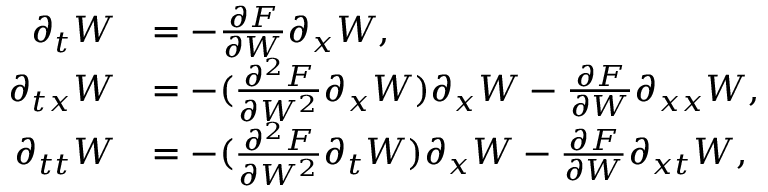<formula> <loc_0><loc_0><loc_500><loc_500>\begin{array} { r l } { \partial _ { t } W } & { = - \frac { \partial F } { \partial W } \partial _ { x } W , } \\ { \partial _ { t x } W } & { = - ( \frac { \partial ^ { 2 } F } { \partial W ^ { 2 } } \partial _ { x } W ) \partial _ { x } W - \frac { \partial F } { \partial W } \partial _ { x x } W , } \\ { \partial _ { t t } W } & { = - ( \frac { \partial ^ { 2 } F } { \partial W ^ { 2 } } \partial _ { t } W ) \partial _ { x } W - \frac { \partial F } { \partial W } \partial _ { x t } W , } \end{array}</formula> 